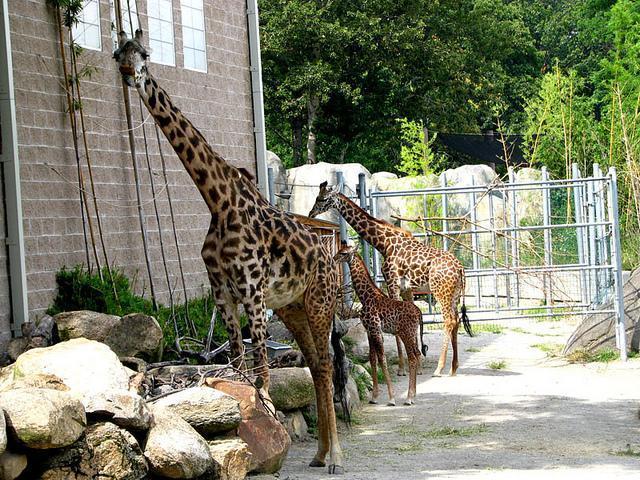How many giraffes are there?
Give a very brief answer. 3. 